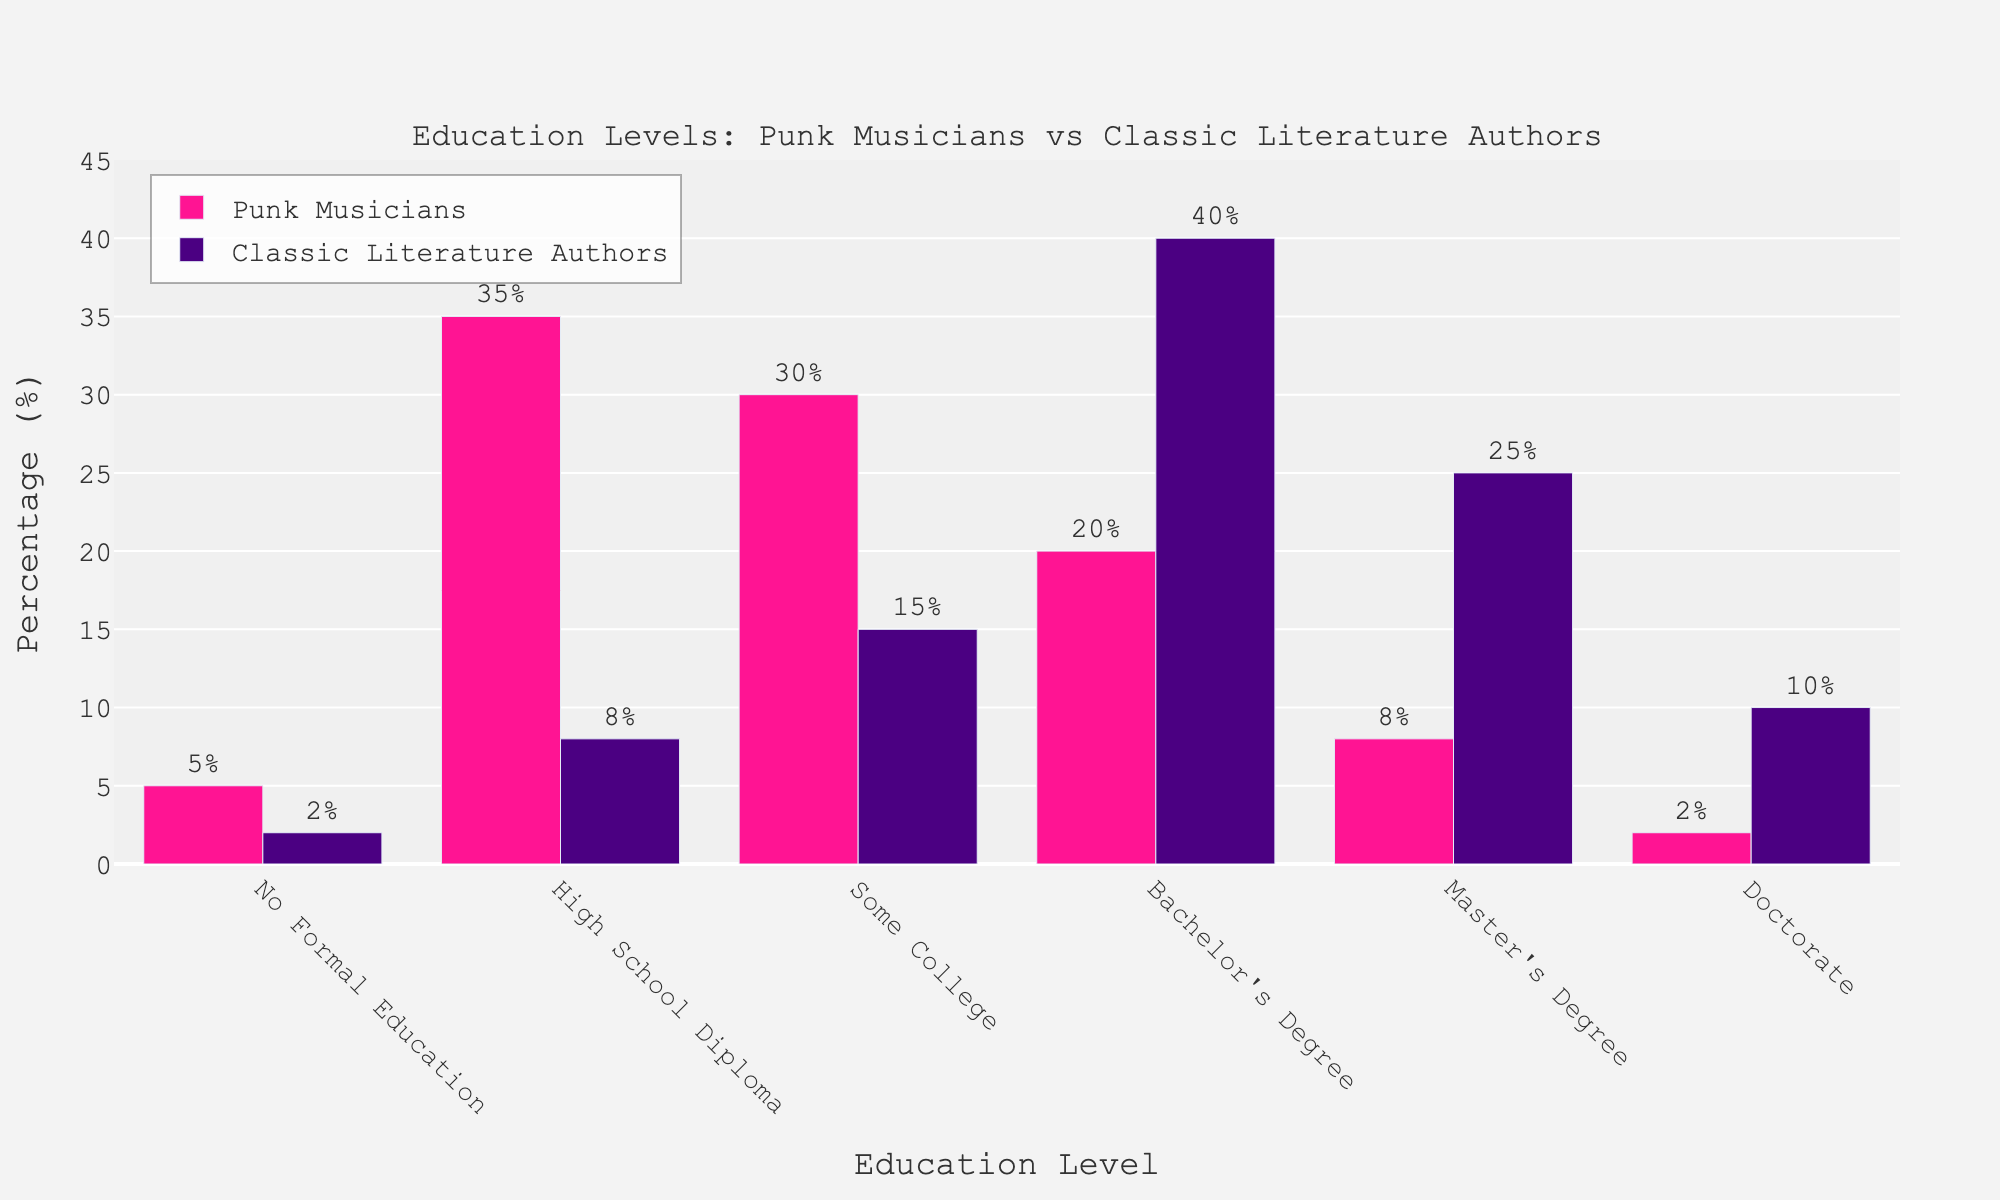what is the difference in percentage between punk musicians and classic literature authors with a bachelor's degree? According to the chart, punk musicians with a bachelor's degree constitute 20%, while classic literature authors are at 40%. The difference is found by subtracting 20% from 40%.
Answer: 20% Which education level shows the largest difference in representation between punk musicians and classic literature authors? The chart shows the biggest difference at the high school diploma level: 35% for punk musicians compared to 8% for classic literature authors. The difference is 27 percentage points.
Answer: High school diploma What is the combined percentage of punk musicians who have some college or a bachelor's degree? For punk musicians, the "Some College" and "Bachelor's Degree" categories are 30% and 20%, respectively. Summing these values, we get 30% + 20% = 50%.
Answer: 50% Among punk musicians and classic literature authors, which group has a higher percentage with a doctorate? The figure shows that 10% of classic literature authors have doctorates compared to 2% of punk musicians. Therefore, classic literature authors have a higher percentage.
Answer: Classic literature authors What is the total percentage of classic literature authors with at least a master's degree? Summing the master's and doctorate percentages for classic literature authors: 25% (Master's Degree) + 10% (Doctorate) = 35%.
Answer: 35% What's the percentage difference in "No Formal Education" levels between punk musicians and classic literature authors? Punk musicians have 5%, while classic literature authors have 2% in "No Formal Education." The difference is 5% - 2% = 3%.
Answer: 3% How does the percentage of punk musicians with no formal education visually compare to classic literature authors with no formal education? The bar for punk musicians in no formal education is taller than that for classic literature authors because it stands at 5% while the latter is at 2%.
Answer: Punk musicians In which education category are punk musicians and classic literature authors most similar? In the "Some College" category, punk musicians have 30%, and classic literature authors have 15%. Despite this, the smallest difference in values is provided by other categories less consistently.
Answer: Some College What's the largest educational category for punk musicians? The tallest bar for punk musicians is "High School Diploma," which is at 35%.
Answer: High School Diploma Which group has a higher proportion with a master's degree? The bar for classic literature authors is taller and stands at 25%, while the bar for punk musicians is at 8%.
Answer: Classic literature authors 